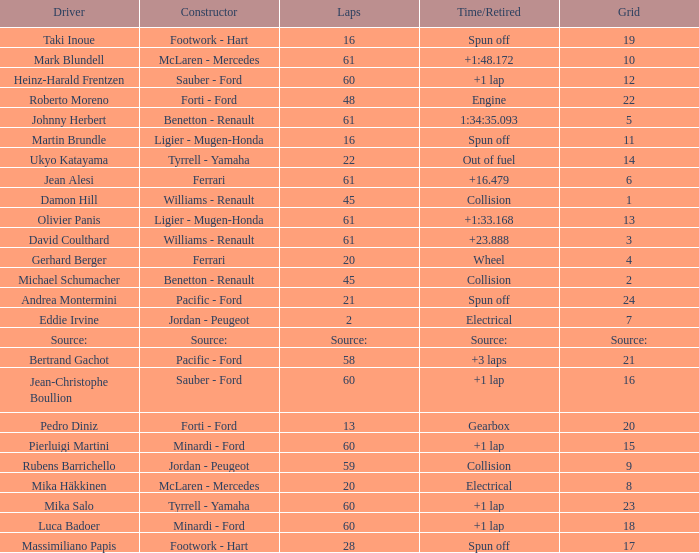What's the time/retired for constructor source:? Source:. 